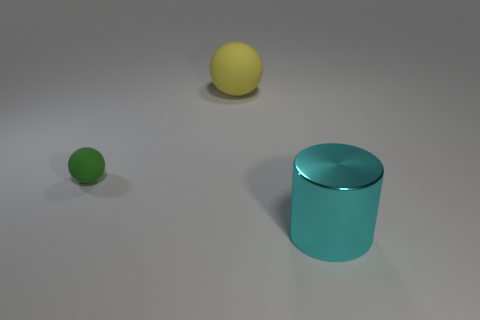How many other objects are there of the same material as the big cylinder?
Offer a terse response. 0. Are there more cyan rubber balls than yellow balls?
Your answer should be compact. No. What is the material of the ball in front of the object behind the rubber thing that is in front of the big yellow ball?
Ensure brevity in your answer.  Rubber. Do the small matte sphere and the big ball have the same color?
Provide a short and direct response. No. Is there a tiny object that has the same color as the large sphere?
Provide a short and direct response. No. There is a yellow rubber object that is the same size as the cylinder; what shape is it?
Give a very brief answer. Sphere. Is the number of big gray metal spheres less than the number of large matte balls?
Keep it short and to the point. Yes. What number of green balls have the same size as the metal cylinder?
Keep it short and to the point. 0. What is the cyan cylinder made of?
Make the answer very short. Metal. How big is the thing that is behind the tiny green object?
Provide a short and direct response. Large. 